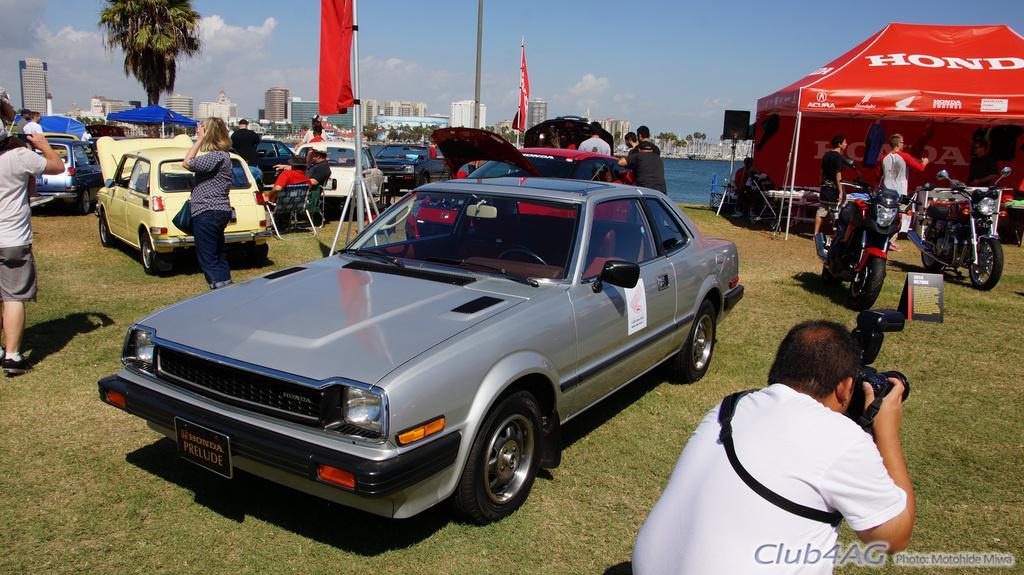Can you describe this image briefly? In this image there is the sky truncated towards the top of the image, there are clouds in the sky, there are buildings, there is water, there are trees, there is a tree truncated towards the top of the image, there are poles truncated towards the top of the image, there are flags, there is a flag truncated towards the top of the image, there is a tent truncated towards the right of the image, there is text on the tent, there are vehicles, there are persons, there is a person truncated towards the bottom of the image, there is a person holding an object, there is person truncated towards the left of the image, there is text towards the bottom of the image, there is grass truncated towards the bottom of the image, there are objects on the grass, there is grass truncated towards the right of the image. 